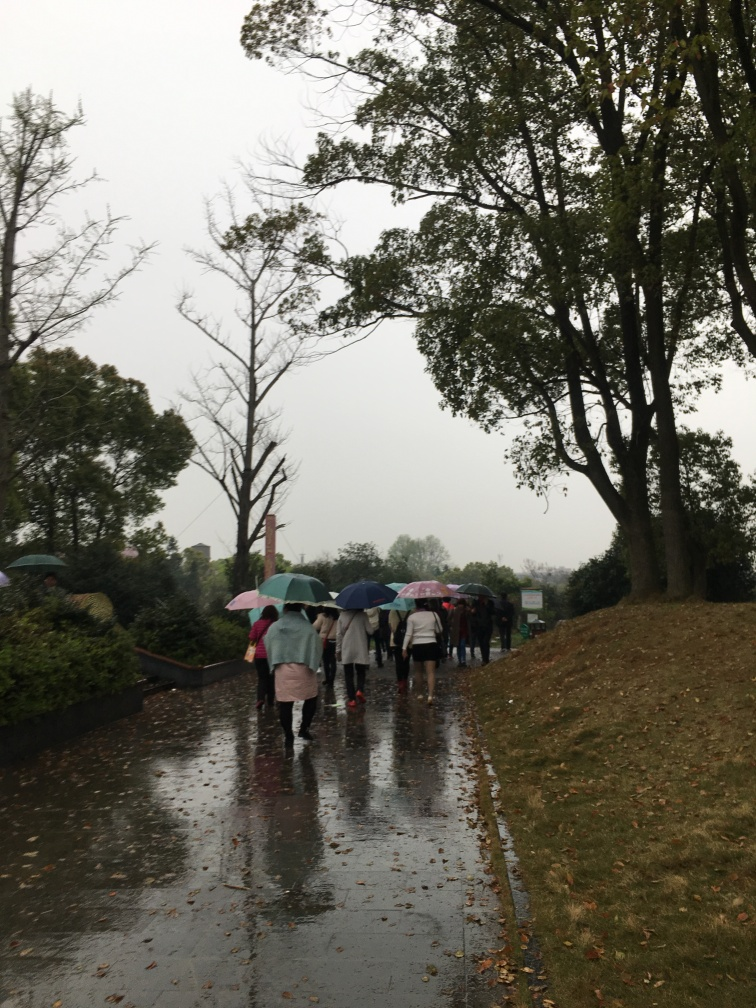Can you describe the weather conditions captured in this image? The image captures a group of people on a wet pavement, likely after or during rainfall, as inferred from the umbrellas they are carrying and the reflective sheen on the ground. Overcast skies suggest it might still be drizzling or that the downpour has recently subsided. 